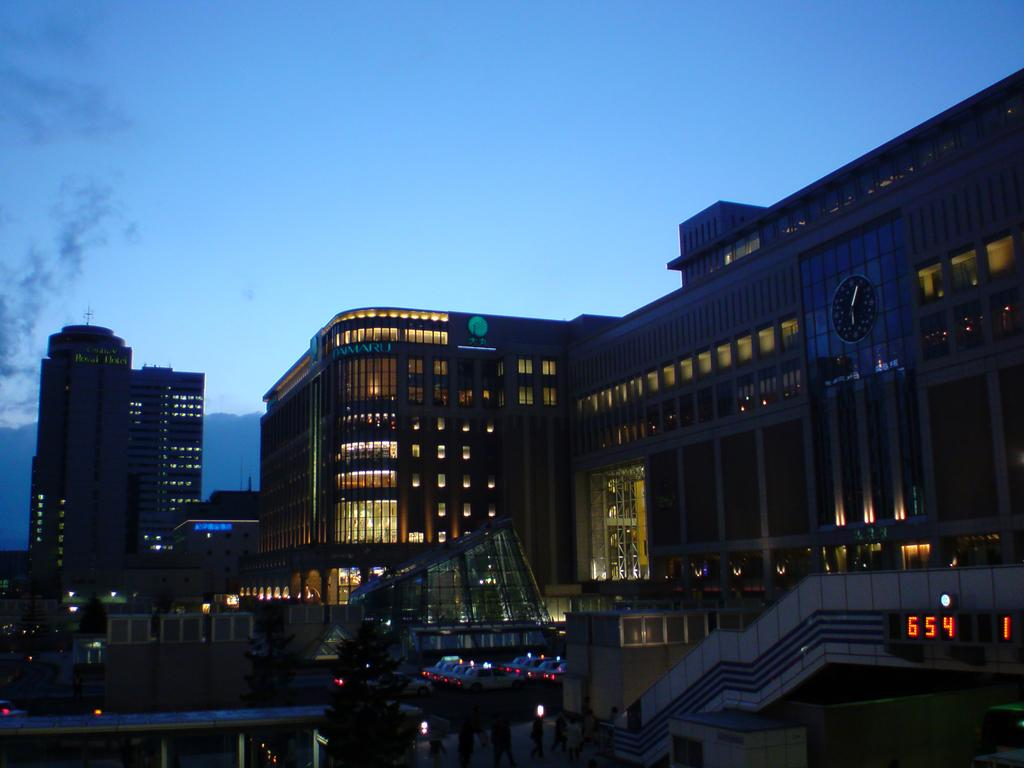What type of structures are present in the image? There are tower buildings in the image. What else can be seen in the image besides the buildings? Vehicles are parked in the image, and there are trees present as well. What electronic device is visible in the image? There is an LED display board in the image. What can be seen illuminating the scene in the image? Lights are visible in the image. How would you describe the sky in the background of the image? The sky in the background is dark. Can you tell me how many arguments are taking place in the image? There is no indication of any arguments occurring in the image. What level of experience does the beginner have in the image? There is no reference to a beginner or any experience level in the image. 